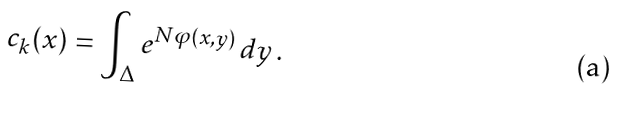<formula> <loc_0><loc_0><loc_500><loc_500>c _ { k } ( x ) = \int _ { \Delta } e ^ { N \varphi ( x , y ) } \, d y \, .</formula> 